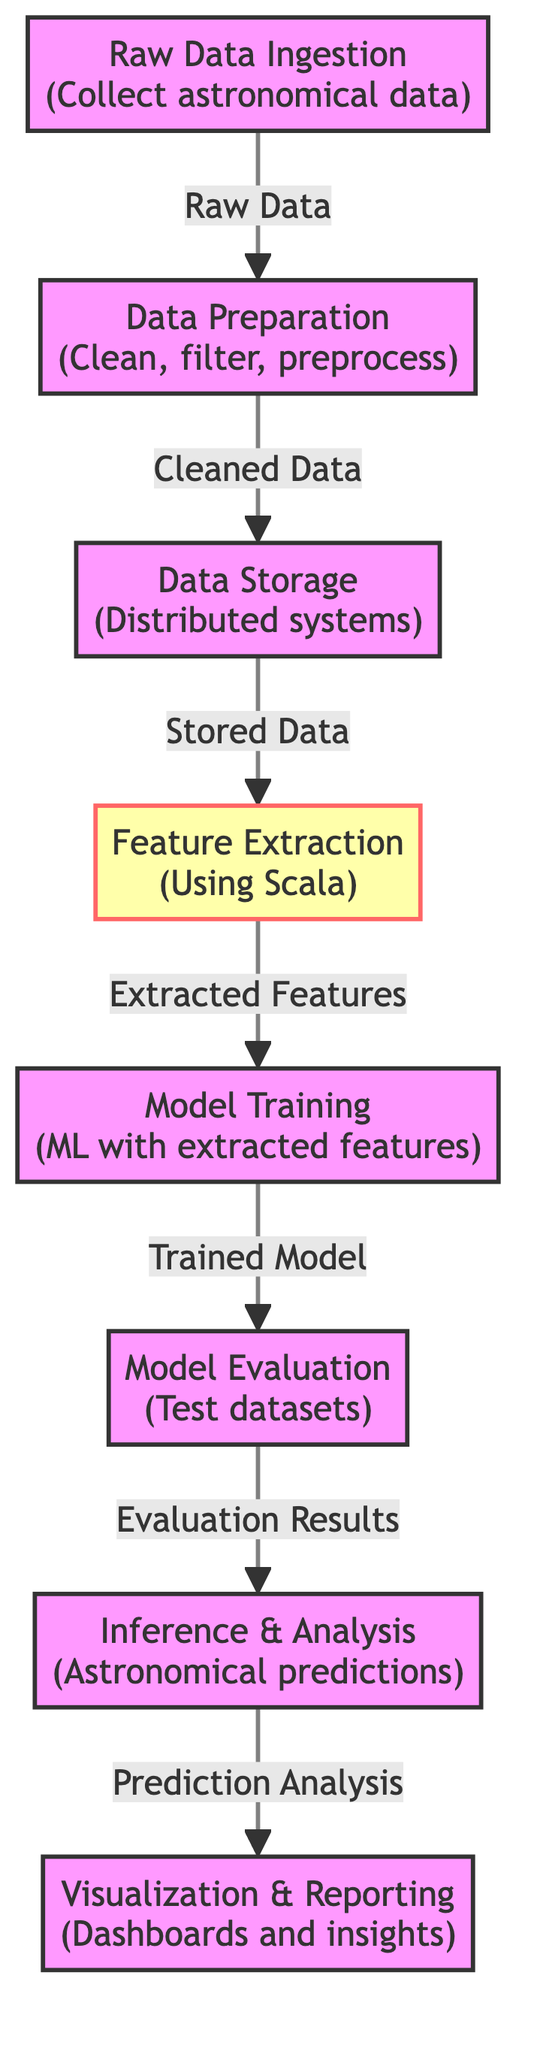What is the first step in the workflow? The first step in the workflow is "Raw Data Ingestion", where astronomical data is collected.
Answer: Raw Data Ingestion How many nodes are there in the diagram? There are eight nodes in the diagram, each representing a step in the workflow.
Answer: 8 What type of data is produced after the "Data Preparation" step? The data produced after the "Data Preparation" step is "Cleaned Data", which is then moved to the next node.
Answer: Cleaned Data Which step uses Scala? The "Feature Extraction" step uses Scala as indicated by the specific styling associated with that node.
Answer: Feature Extraction What is the final outcome of the workflow? The final outcome of the workflow is "Visualization & Reporting," where dashboards and insights are generated.
Answer: Visualization & Reporting What flows from "Model Evaluation" to "Inference & Analysis"? The flow from "Model Evaluation" to "Inference & Analysis" is the "Evaluation Results."
Answer: Evaluation Results What is the relationship between "Data Storage" and "Feature Extraction"? The relationship is that "Data Storage" provides "Stored Data" to "Feature Extraction" for further processing.
Answer: Stored Data How does "Feature Extraction" contribute to the overall workflow? "Feature Extraction" contributes by providing "Extracted Features" which are essential for the "Model Training" step.
Answer: Extracted Features What are the two types of data processed in the workflow before the "Model Training"? The two types of data processed before "Model Training" are "Cleaned Data" and "Extracted Features."
Answer: Cleaned Data, Extracted Features 